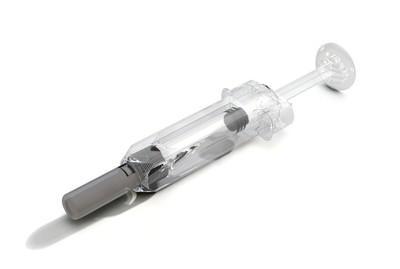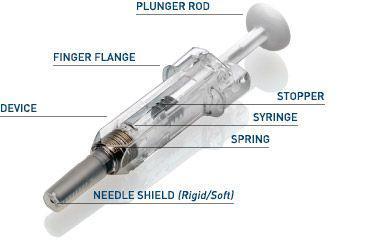The first image is the image on the left, the second image is the image on the right. Given the left and right images, does the statement "A total of two syringes are shown." hold true? Answer yes or no. Yes. 